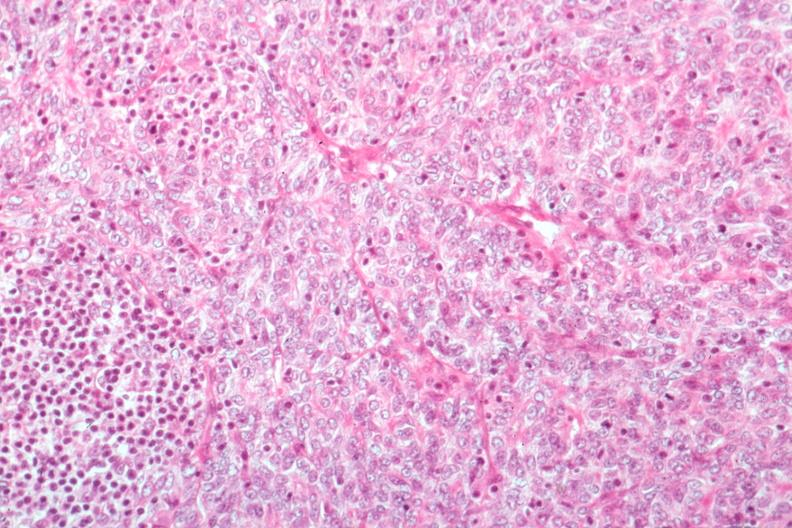does this image show predominant epithelial excellent histology?
Answer the question using a single word or phrase. Yes 